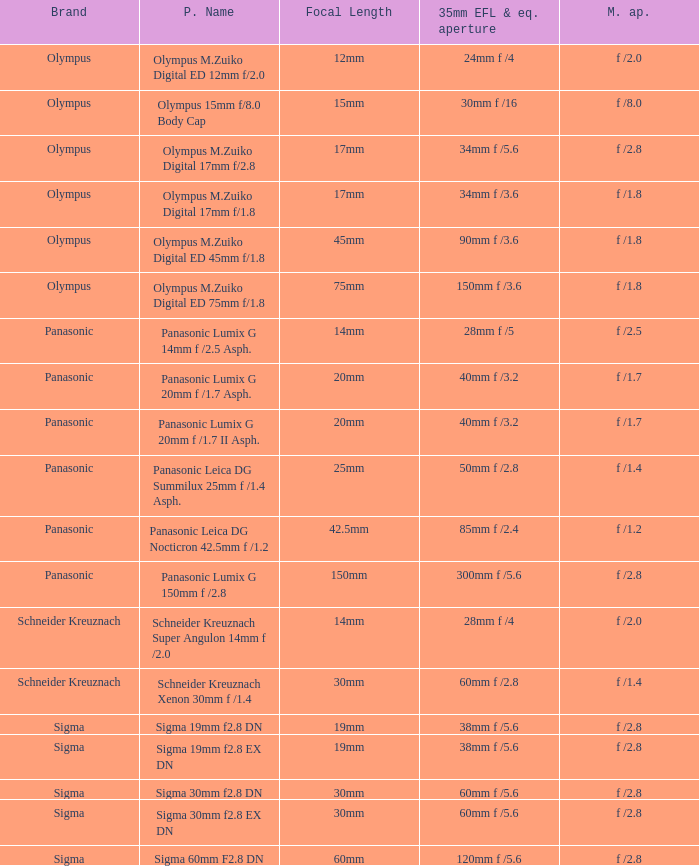What is the brand of the Sigma 30mm f2.8 DN, which has a maximum aperture of f /2.8 and a focal length of 30mm? Sigma. 